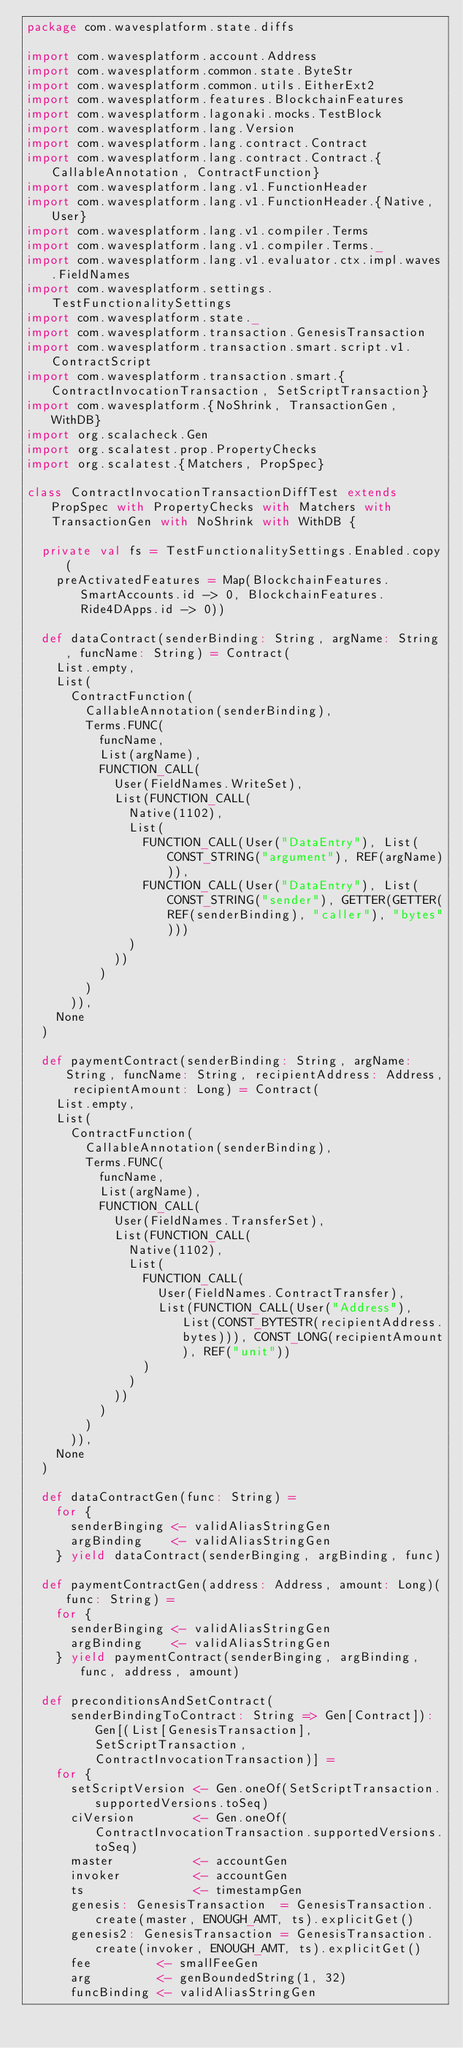<code> <loc_0><loc_0><loc_500><loc_500><_Scala_>package com.wavesplatform.state.diffs

import com.wavesplatform.account.Address
import com.wavesplatform.common.state.ByteStr
import com.wavesplatform.common.utils.EitherExt2
import com.wavesplatform.features.BlockchainFeatures
import com.wavesplatform.lagonaki.mocks.TestBlock
import com.wavesplatform.lang.Version
import com.wavesplatform.lang.contract.Contract
import com.wavesplatform.lang.contract.Contract.{CallableAnnotation, ContractFunction}
import com.wavesplatform.lang.v1.FunctionHeader
import com.wavesplatform.lang.v1.FunctionHeader.{Native, User}
import com.wavesplatform.lang.v1.compiler.Terms
import com.wavesplatform.lang.v1.compiler.Terms._
import com.wavesplatform.lang.v1.evaluator.ctx.impl.waves.FieldNames
import com.wavesplatform.settings.TestFunctionalitySettings
import com.wavesplatform.state._
import com.wavesplatform.transaction.GenesisTransaction
import com.wavesplatform.transaction.smart.script.v1.ContractScript
import com.wavesplatform.transaction.smart.{ContractInvocationTransaction, SetScriptTransaction}
import com.wavesplatform.{NoShrink, TransactionGen, WithDB}
import org.scalacheck.Gen
import org.scalatest.prop.PropertyChecks
import org.scalatest.{Matchers, PropSpec}

class ContractInvocationTransactionDiffTest extends PropSpec with PropertyChecks with Matchers with TransactionGen with NoShrink with WithDB {

  private val fs = TestFunctionalitySettings.Enabled.copy(
    preActivatedFeatures = Map(BlockchainFeatures.SmartAccounts.id -> 0, BlockchainFeatures.Ride4DApps.id -> 0))

  def dataContract(senderBinding: String, argName: String, funcName: String) = Contract(
    List.empty,
    List(
      ContractFunction(
        CallableAnnotation(senderBinding),
        Terms.FUNC(
          funcName,
          List(argName),
          FUNCTION_CALL(
            User(FieldNames.WriteSet),
            List(FUNCTION_CALL(
              Native(1102),
              List(
                FUNCTION_CALL(User("DataEntry"), List(CONST_STRING("argument"), REF(argName))),
                FUNCTION_CALL(User("DataEntry"), List(CONST_STRING("sender"), GETTER(GETTER(REF(senderBinding), "caller"), "bytes")))
              )
            ))
          )
        )
      )),
    None
  )

  def paymentContract(senderBinding: String, argName: String, funcName: String, recipientAddress: Address, recipientAmount: Long) = Contract(
    List.empty,
    List(
      ContractFunction(
        CallableAnnotation(senderBinding),
        Terms.FUNC(
          funcName,
          List(argName),
          FUNCTION_CALL(
            User(FieldNames.TransferSet),
            List(FUNCTION_CALL(
              Native(1102),
              List(
                FUNCTION_CALL(
                  User(FieldNames.ContractTransfer),
                  List(FUNCTION_CALL(User("Address"), List(CONST_BYTESTR(recipientAddress.bytes))), CONST_LONG(recipientAmount), REF("unit"))
                )
              )
            ))
          )
        )
      )),
    None
  )

  def dataContractGen(func: String) =
    for {
      senderBinging <- validAliasStringGen
      argBinding    <- validAliasStringGen
    } yield dataContract(senderBinging, argBinding, func)

  def paymentContractGen(address: Address, amount: Long)(func: String) =
    for {
      senderBinging <- validAliasStringGen
      argBinding    <- validAliasStringGen
    } yield paymentContract(senderBinging, argBinding, func, address, amount)

  def preconditionsAndSetContract(
      senderBindingToContract: String => Gen[Contract]): Gen[(List[GenesisTransaction], SetScriptTransaction, ContractInvocationTransaction)] =
    for {
      setScriptVersion <- Gen.oneOf(SetScriptTransaction.supportedVersions.toSeq)
      ciVersion        <- Gen.oneOf(ContractInvocationTransaction.supportedVersions.toSeq)
      master           <- accountGen
      invoker          <- accountGen
      ts               <- timestampGen
      genesis: GenesisTransaction  = GenesisTransaction.create(master, ENOUGH_AMT, ts).explicitGet()
      genesis2: GenesisTransaction = GenesisTransaction.create(invoker, ENOUGH_AMT, ts).explicitGet()
      fee         <- smallFeeGen
      arg         <- genBoundedString(1, 32)
      funcBinding <- validAliasStringGen</code> 